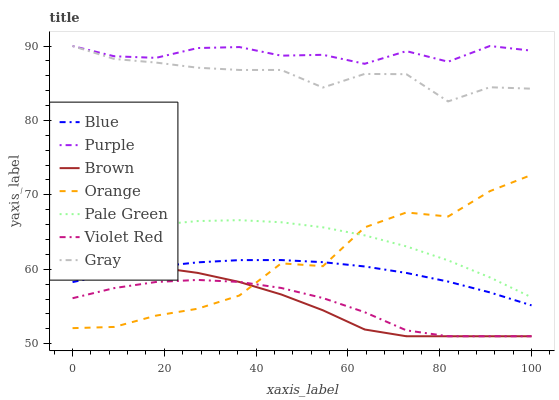Does Violet Red have the minimum area under the curve?
Answer yes or no. Yes. Does Purple have the maximum area under the curve?
Answer yes or no. Yes. Does Brown have the minimum area under the curve?
Answer yes or no. No. Does Brown have the maximum area under the curve?
Answer yes or no. No. Is Blue the smoothest?
Answer yes or no. Yes. Is Orange the roughest?
Answer yes or no. Yes. Is Brown the smoothest?
Answer yes or no. No. Is Brown the roughest?
Answer yes or no. No. Does Brown have the lowest value?
Answer yes or no. Yes. Does Gray have the lowest value?
Answer yes or no. No. Does Purple have the highest value?
Answer yes or no. Yes. Does Brown have the highest value?
Answer yes or no. No. Is Pale Green less than Gray?
Answer yes or no. Yes. Is Pale Green greater than Brown?
Answer yes or no. Yes. Does Orange intersect Brown?
Answer yes or no. Yes. Is Orange less than Brown?
Answer yes or no. No. Is Orange greater than Brown?
Answer yes or no. No. Does Pale Green intersect Gray?
Answer yes or no. No. 